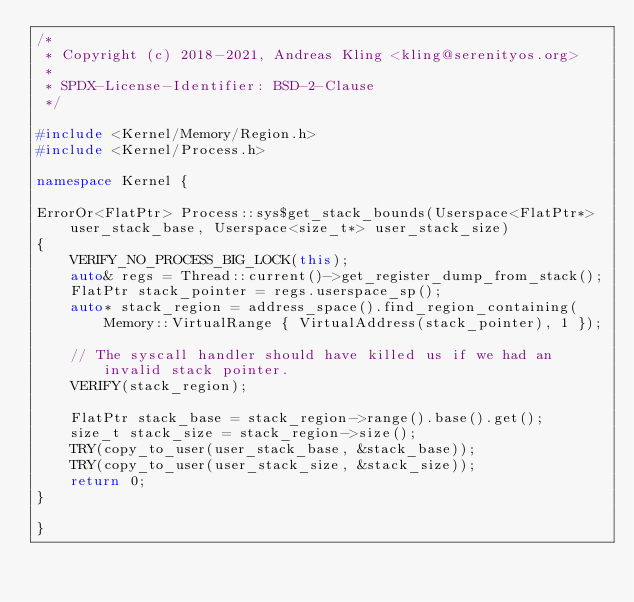Convert code to text. <code><loc_0><loc_0><loc_500><loc_500><_C++_>/*
 * Copyright (c) 2018-2021, Andreas Kling <kling@serenityos.org>
 *
 * SPDX-License-Identifier: BSD-2-Clause
 */

#include <Kernel/Memory/Region.h>
#include <Kernel/Process.h>

namespace Kernel {

ErrorOr<FlatPtr> Process::sys$get_stack_bounds(Userspace<FlatPtr*> user_stack_base, Userspace<size_t*> user_stack_size)
{
    VERIFY_NO_PROCESS_BIG_LOCK(this);
    auto& regs = Thread::current()->get_register_dump_from_stack();
    FlatPtr stack_pointer = regs.userspace_sp();
    auto* stack_region = address_space().find_region_containing(Memory::VirtualRange { VirtualAddress(stack_pointer), 1 });

    // The syscall handler should have killed us if we had an invalid stack pointer.
    VERIFY(stack_region);

    FlatPtr stack_base = stack_region->range().base().get();
    size_t stack_size = stack_region->size();
    TRY(copy_to_user(user_stack_base, &stack_base));
    TRY(copy_to_user(user_stack_size, &stack_size));
    return 0;
}

}
</code> 